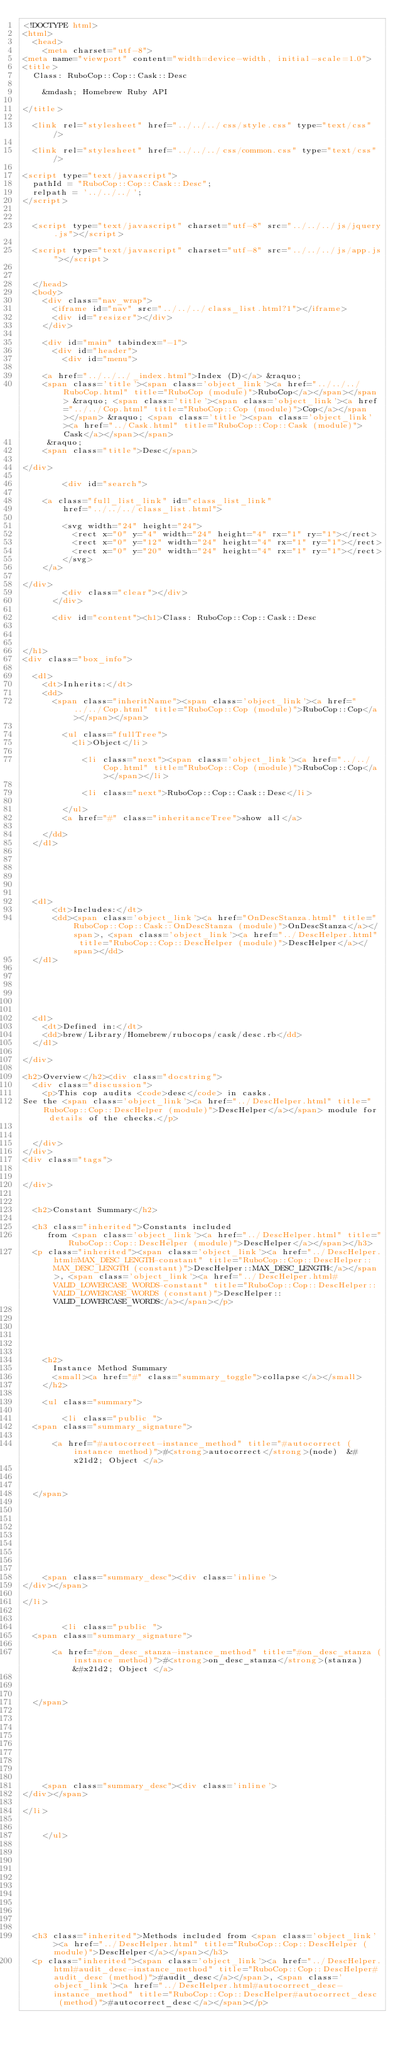Convert code to text. <code><loc_0><loc_0><loc_500><loc_500><_HTML_><!DOCTYPE html>
<html>
  <head>
    <meta charset="utf-8">
<meta name="viewport" content="width=device-width, initial-scale=1.0">
<title>
  Class: RuboCop::Cop::Cask::Desc
  
    &mdash; Homebrew Ruby API
  
</title>

  <link rel="stylesheet" href="../../../css/style.css" type="text/css" />

  <link rel="stylesheet" href="../../../css/common.css" type="text/css" />

<script type="text/javascript">
  pathId = "RuboCop::Cop::Cask::Desc";
  relpath = '../../../';
</script>


  <script type="text/javascript" charset="utf-8" src="../../../js/jquery.js"></script>

  <script type="text/javascript" charset="utf-8" src="../../../js/app.js"></script>


  </head>
  <body>
    <div class="nav_wrap">
      <iframe id="nav" src="../../../class_list.html?1"></iframe>
      <div id="resizer"></div>
    </div>

    <div id="main" tabindex="-1">
      <div id="header">
        <div id="menu">
  
    <a href="../../../_index.html">Index (D)</a> &raquo;
    <span class='title'><span class='object_link'><a href="../../../RuboCop.html" title="RuboCop (module)">RuboCop</a></span></span> &raquo; <span class='title'><span class='object_link'><a href="../../Cop.html" title="RuboCop::Cop (module)">Cop</a></span></span> &raquo; <span class='title'><span class='object_link'><a href="../Cask.html" title="RuboCop::Cop::Cask (module)">Cask</a></span></span>
     &raquo; 
    <span class="title">Desc</span>
  
</div>

        <div id="search">
  
    <a class="full_list_link" id="class_list_link"
        href="../../../class_list.html">

        <svg width="24" height="24">
          <rect x="0" y="4" width="24" height="4" rx="1" ry="1"></rect>
          <rect x="0" y="12" width="24" height="4" rx="1" ry="1"></rect>
          <rect x="0" y="20" width="24" height="4" rx="1" ry="1"></rect>
        </svg>
    </a>
  
</div>
        <div class="clear"></div>
      </div>

      <div id="content"><h1>Class: RuboCop::Cop::Cask::Desc
  
  
  
</h1>
<div class="box_info">
  
  <dl>
    <dt>Inherits:</dt>
    <dd>
      <span class="inheritName"><span class='object_link'><a href="../../Cop.html" title="RuboCop::Cop (module)">RuboCop::Cop</a></span></span>
      
        <ul class="fullTree">
          <li>Object</li>
          
            <li class="next"><span class='object_link'><a href="../../Cop.html" title="RuboCop::Cop (module)">RuboCop::Cop</a></span></li>
          
            <li class="next">RuboCop::Cop::Cask::Desc</li>
          
        </ul>
        <a href="#" class="inheritanceTree">show all</a>
      
    </dd>
  </dl>
  

  
  
  
  
  <dl>
      <dt>Includes:</dt>
      <dd><span class='object_link'><a href="OnDescStanza.html" title="RuboCop::Cop::Cask::OnDescStanza (module)">OnDescStanza</a></span>, <span class='object_link'><a href="../DescHelper.html" title="RuboCop::Cop::DescHelper (module)">DescHelper</a></span></dd>
  </dl>
  
  

  

  
  <dl>
    <dt>Defined in:</dt>
    <dd>brew/Library/Homebrew/rubocops/cask/desc.rb</dd>
  </dl>
  
</div>

<h2>Overview</h2><div class="docstring">
  <div class="discussion">
    <p>This cop audits <code>desc</code> in casks.
See the <span class='object_link'><a href="../DescHelper.html" title="RuboCop::Cop::DescHelper (module)">DescHelper</a></span> module for details of the checks.</p>


  </div>
</div>
<div class="tags">
  

</div>


  <h2>Constant Summary</h2>
  
  <h3 class="inherited">Constants included
     from <span class='object_link'><a href="../DescHelper.html" title="RuboCop::Cop::DescHelper (module)">DescHelper</a></span></h3>
  <p class="inherited"><span class='object_link'><a href="../DescHelper.html#MAX_DESC_LENGTH-constant" title="RuboCop::Cop::DescHelper::MAX_DESC_LENGTH (constant)">DescHelper::MAX_DESC_LENGTH</a></span>, <span class='object_link'><a href="../DescHelper.html#VALID_LOWERCASE_WORDS-constant" title="RuboCop::Cop::DescHelper::VALID_LOWERCASE_WORDS (constant)">DescHelper::VALID_LOWERCASE_WORDS</a></span></p>





  
    <h2>
      Instance Method Summary
      <small><a href="#" class="summary_toggle">collapse</a></small>
    </h2>

    <ul class="summary">
      
        <li class="public ">
  <span class="summary_signature">
    
      <a href="#autocorrect-instance_method" title="#autocorrect (instance method)">#<strong>autocorrect</strong>(node)  &#x21d2; Object </a>
    

    
  </span>
  
  
  
  
  
  
  

  
    <span class="summary_desc"><div class='inline'>
</div></span>
  
</li>

      
        <li class="public ">
  <span class="summary_signature">
    
      <a href="#on_desc_stanza-instance_method" title="#on_desc_stanza (instance method)">#<strong>on_desc_stanza</strong>(stanza)  &#x21d2; Object </a>
    

    
  </span>
  
  
  
  
  
  
  

  
    <span class="summary_desc"><div class='inline'>
</div></span>
  
</li>

      
    </ul>
  


  
  
  
  
  
  
  
  
  <h3 class="inherited">Methods included from <span class='object_link'><a href="../DescHelper.html" title="RuboCop::Cop::DescHelper (module)">DescHelper</a></span></h3>
  <p class="inherited"><span class='object_link'><a href="../DescHelper.html#audit_desc-instance_method" title="RuboCop::Cop::DescHelper#audit_desc (method)">#audit_desc</a></span>, <span class='object_link'><a href="../DescHelper.html#autocorrect_desc-instance_method" title="RuboCop::Cop::DescHelper#autocorrect_desc (method)">#autocorrect_desc</a></span></p>

  
  
  
  
  
  
  
  </code> 